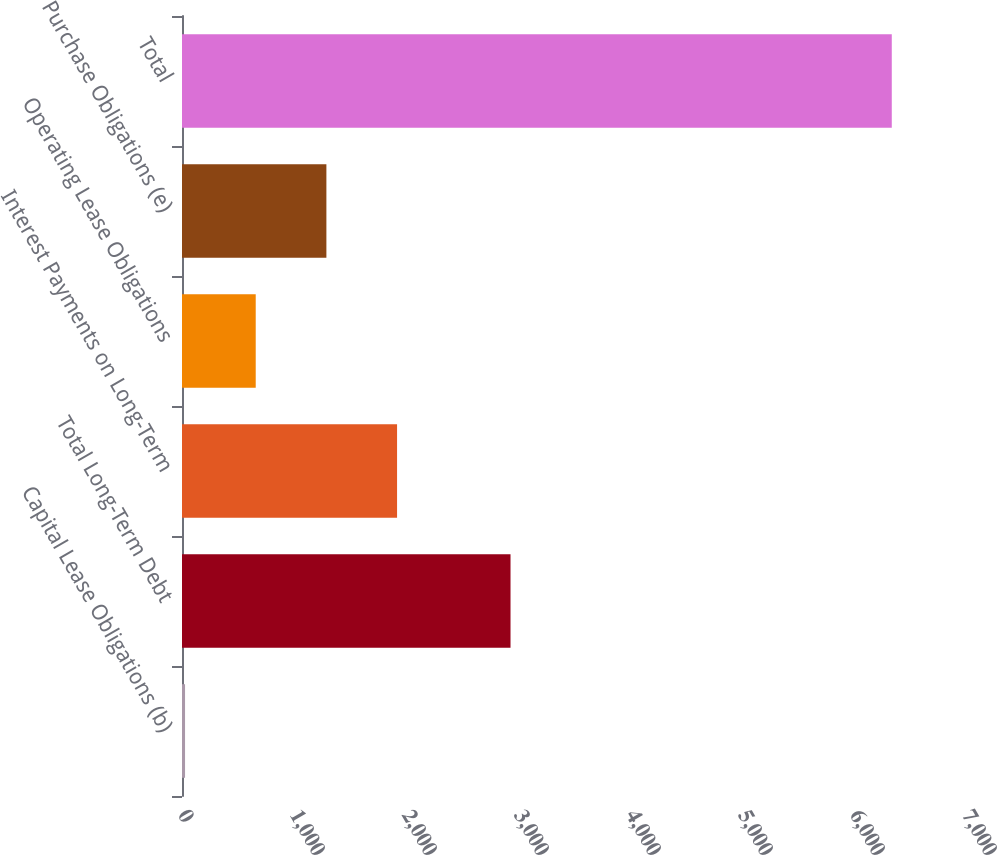Convert chart. <chart><loc_0><loc_0><loc_500><loc_500><bar_chart><fcel>Capital Lease Obligations (b)<fcel>Total Long-Term Debt<fcel>Interest Payments on Long-Term<fcel>Operating Lease Obligations<fcel>Purchase Obligations (e)<fcel>Total<nl><fcel>27.2<fcel>2933.2<fcel>1920.23<fcel>658.21<fcel>1289.22<fcel>6337.3<nl></chart> 